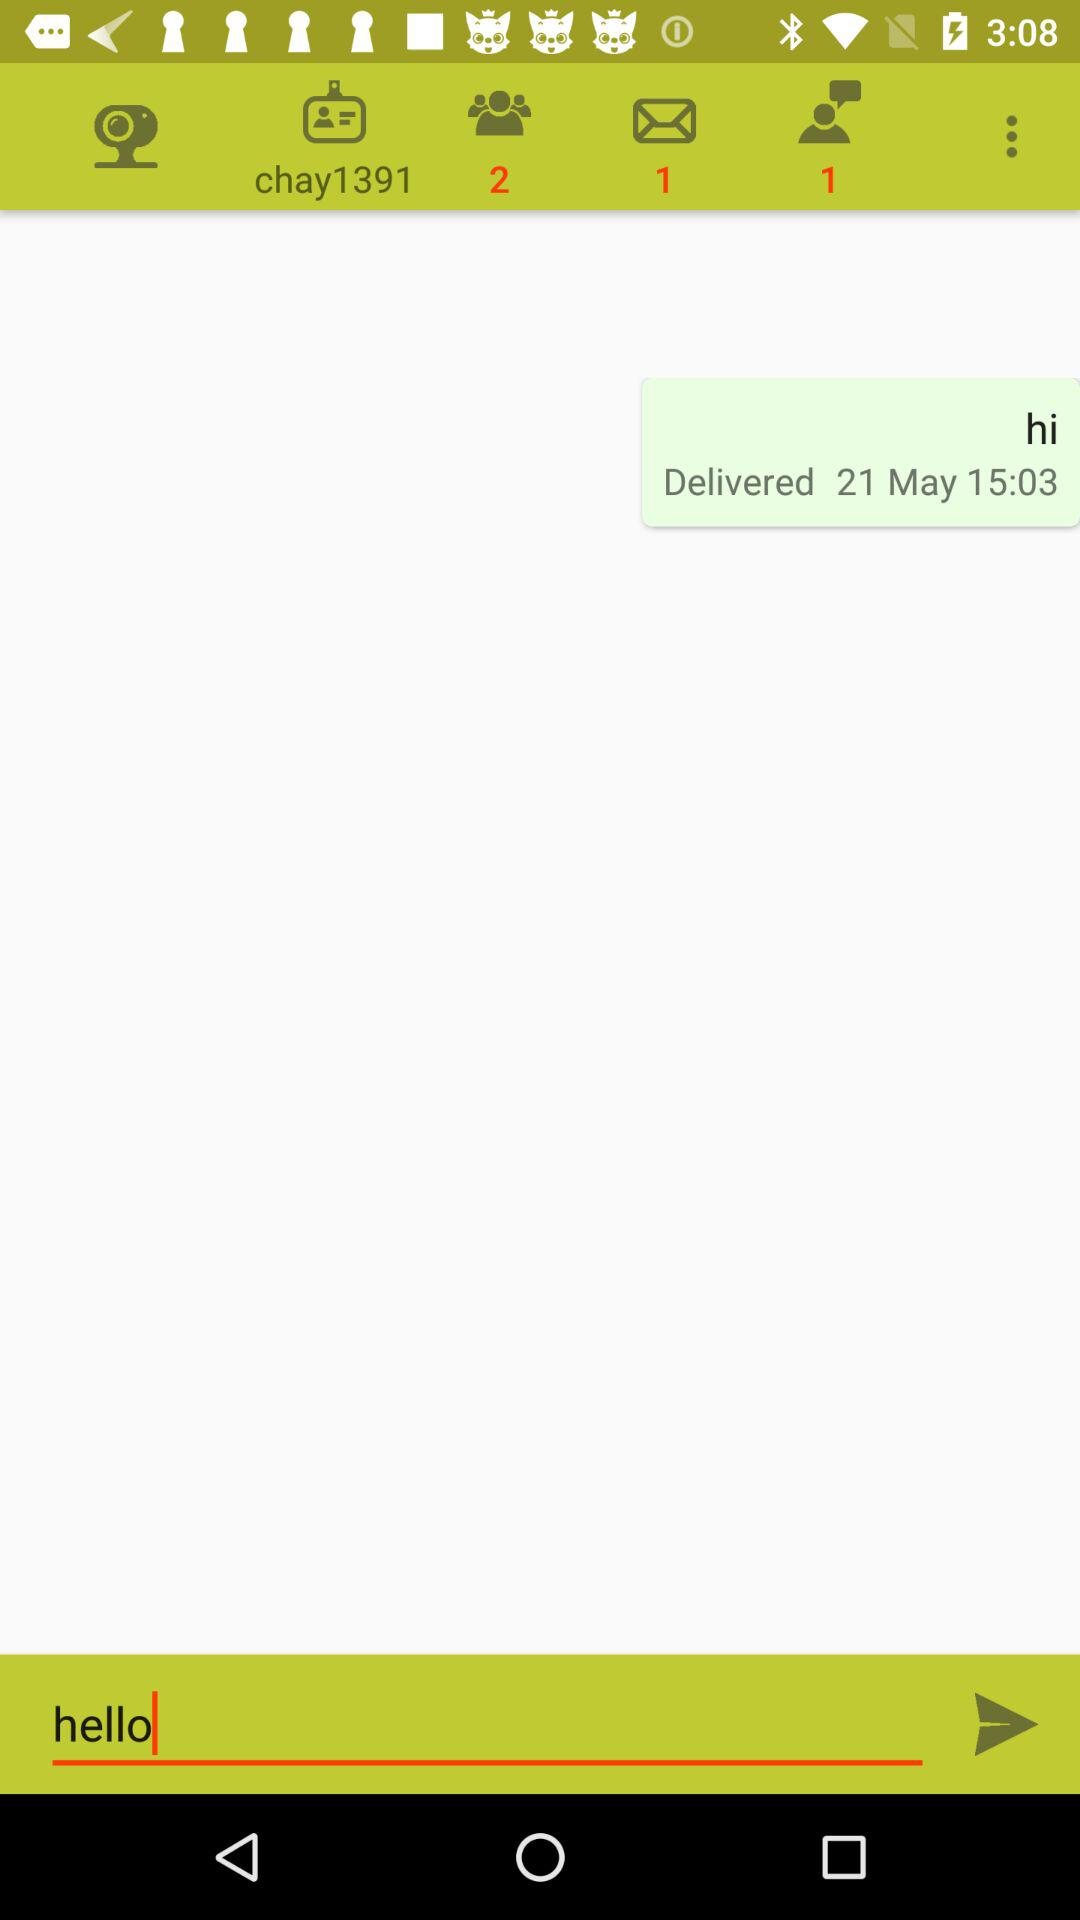On what date was the message delivered? The date is May 21. 